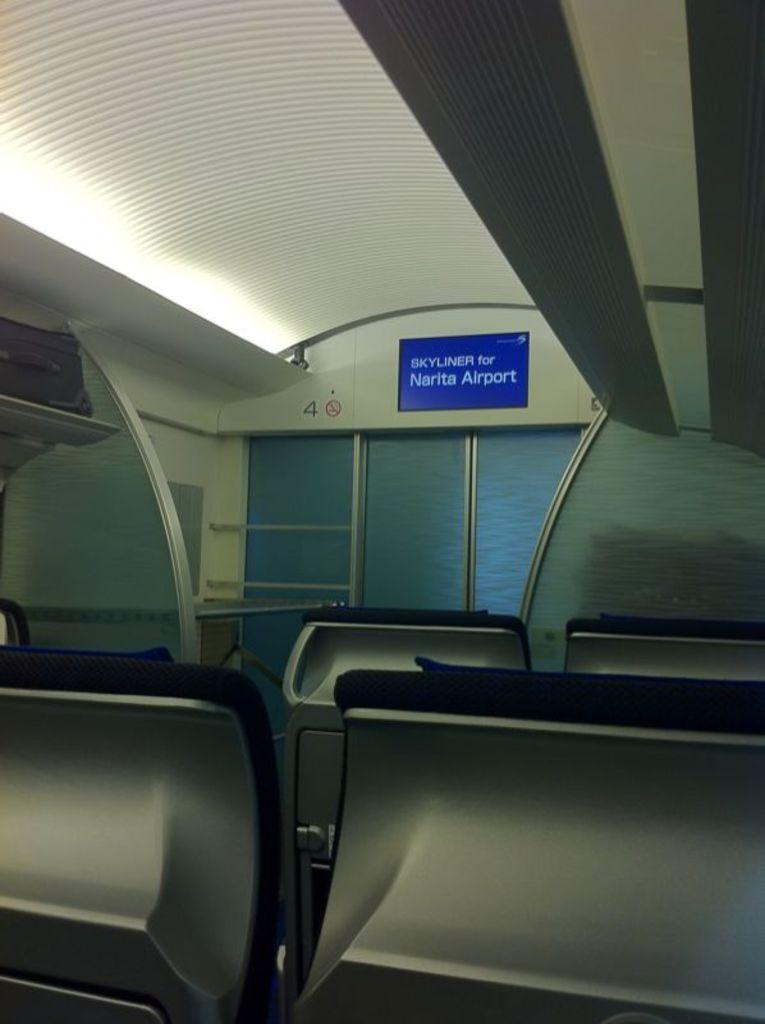What type of location is depicted in the image? The image is an inside view of an aeroplane. What type of furniture is present in the image? There are chairs in the image. What type of structure can be seen in the image? There is a wall in the image. What type of material is present in the image? There is glass in the image. What type of storage feature is present in the image? There is a shelf in the image. What type of personal item is present in the image? There is a bag in the image. What type of display feature is present in the image? There is a board in the image. What type of architectural feature is present in the image? There is a roof in the image. What type of lighting feature is present in the image? There is a light in the image. What type of canvas is visible in the image? There is no canvas present in the image. What type of song is being played in the image? There is no indication of any music or song being played in the image. 